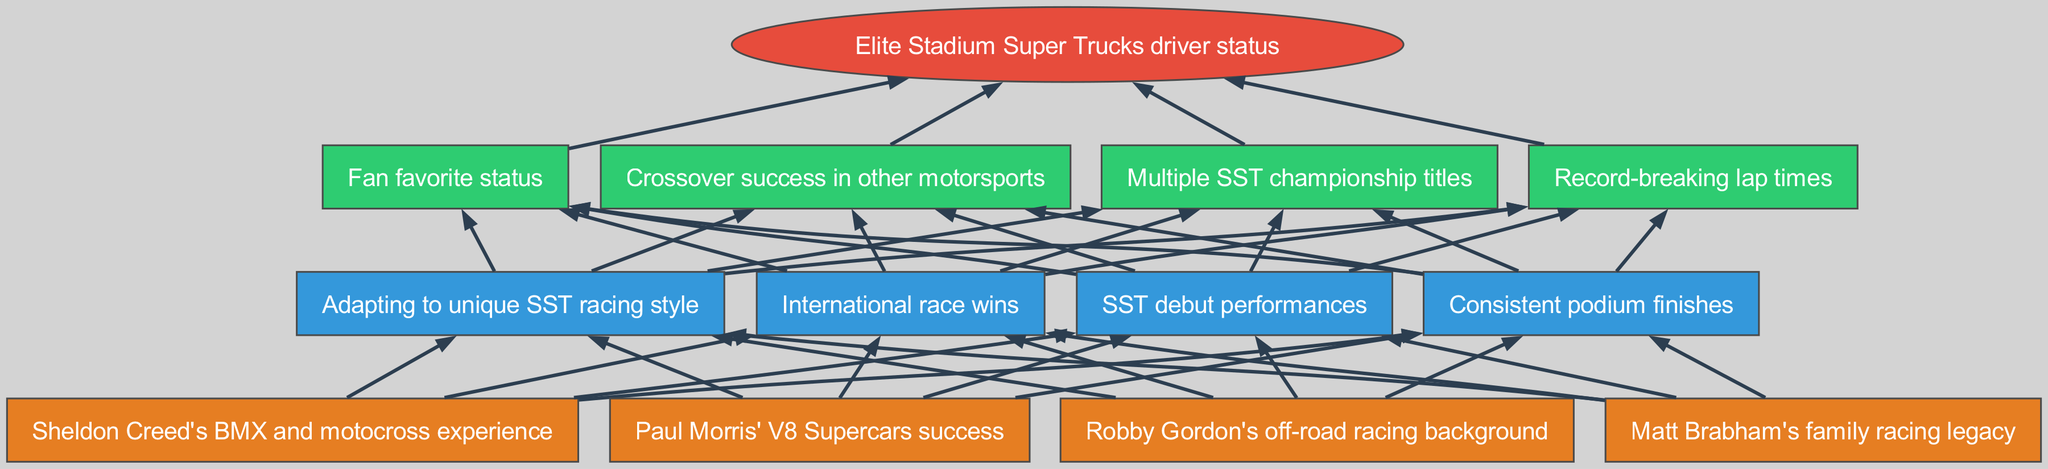What are the names of the four drivers at the bottom level? The bottom level includes Robby Gordon, Matt Brabham, Sheldon Creed, and Paul Morris, which represent their unique backgrounds and achievements in the context of Stadium Super Trucks.
Answer: Robby Gordon, Matt Brabham, Sheldon Creed, Paul Morris How many nodes are there in the middle level? The middle level consists of four nodes: SST debut performances, consistent podium finishes, adapting to unique SST racing style, and international race wins. Therefore, counting these gives a total of four nodes.
Answer: 4 Which node is connected to the apex directly? Each of the top level nodes is directly connected to the apex node, defined as the "elite Stadium Super Trucks driver status," representing the culmination of achievements from all the levels beneath it.
Answer: Multiple SST championship titles, record-breaking lap times, fan favorite status, crossover success in other motorsports Which driver is associated with V8 Supercars success? Paul Morris is specifically linked to V8 Supercars success among the listed drivers in the bottom level, reflecting his achievements prior to transitioning to SST.
Answer: Paul Morris How does one achieve elite status as a driver in this context? Achieving elite status involves progressing through various stages starting from foundational achievements (like drivers' backgrounds), followed by middle-level milestones (such as adapting to SST and achieving notable performances), and culminating in top-level accomplishments (like winning championships and breaking records).
Answer: Multiple SST championship titles, record-breaking lap times, fan favorite status, crossover success in other motorsports Which node in the top level indicates general popularity among fans? The node indicating general popularity among fans in the top level is "fan favorite status," emphasizing the broader appeal a driver can have within the motorsports community and among spectators.
Answer: Fan favorite status How are the bottom and middle levels related in terms of performance? The bottom level nodes represent the drivers’ unique backgrounds and experiences, which feed into the middle level performance nodes, indicating how these foundational factors influence success in SST debut performances and subsequently lead to consistent podium finishes, adapting to SST racing style, and international race wins.
Answer: SST debut performances, consistent podium finishes, adapting to unique SST racing style, international race wins What is the significance of record-breaking lap times? Record-breaking lap times serve as a demonstration of the driver's skill and competitiveness among the top trucks and highlight their achievements in the context of the top-level accomplishments.
Answer: Record-breaking lap times 